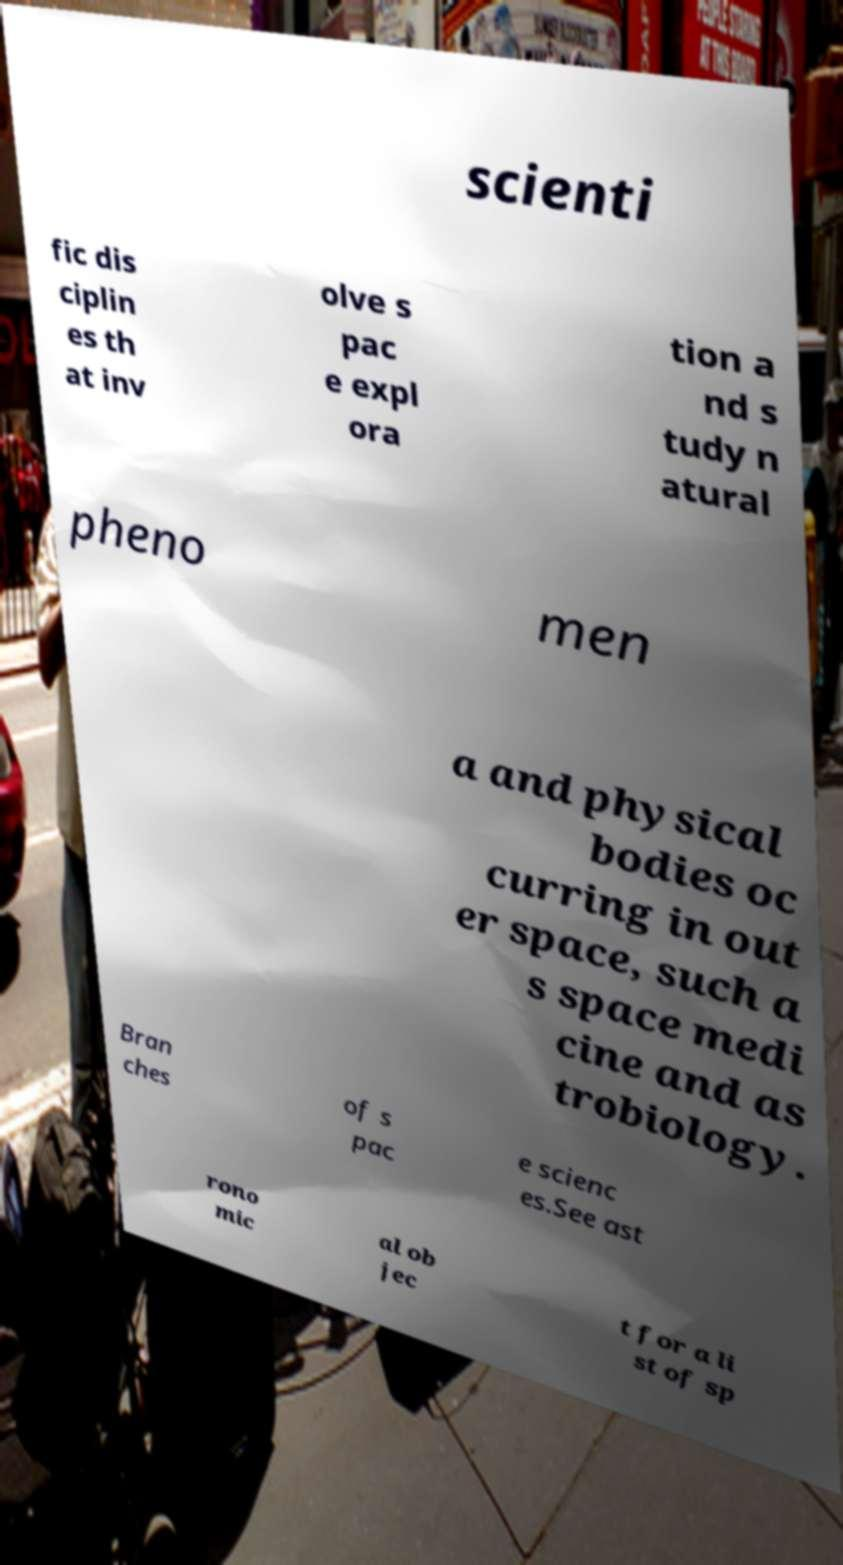Please identify and transcribe the text found in this image. scienti fic dis ciplin es th at inv olve s pac e expl ora tion a nd s tudy n atural pheno men a and physical bodies oc curring in out er space, such a s space medi cine and as trobiology. Bran ches of s pac e scienc es.See ast rono mic al ob jec t for a li st of sp 